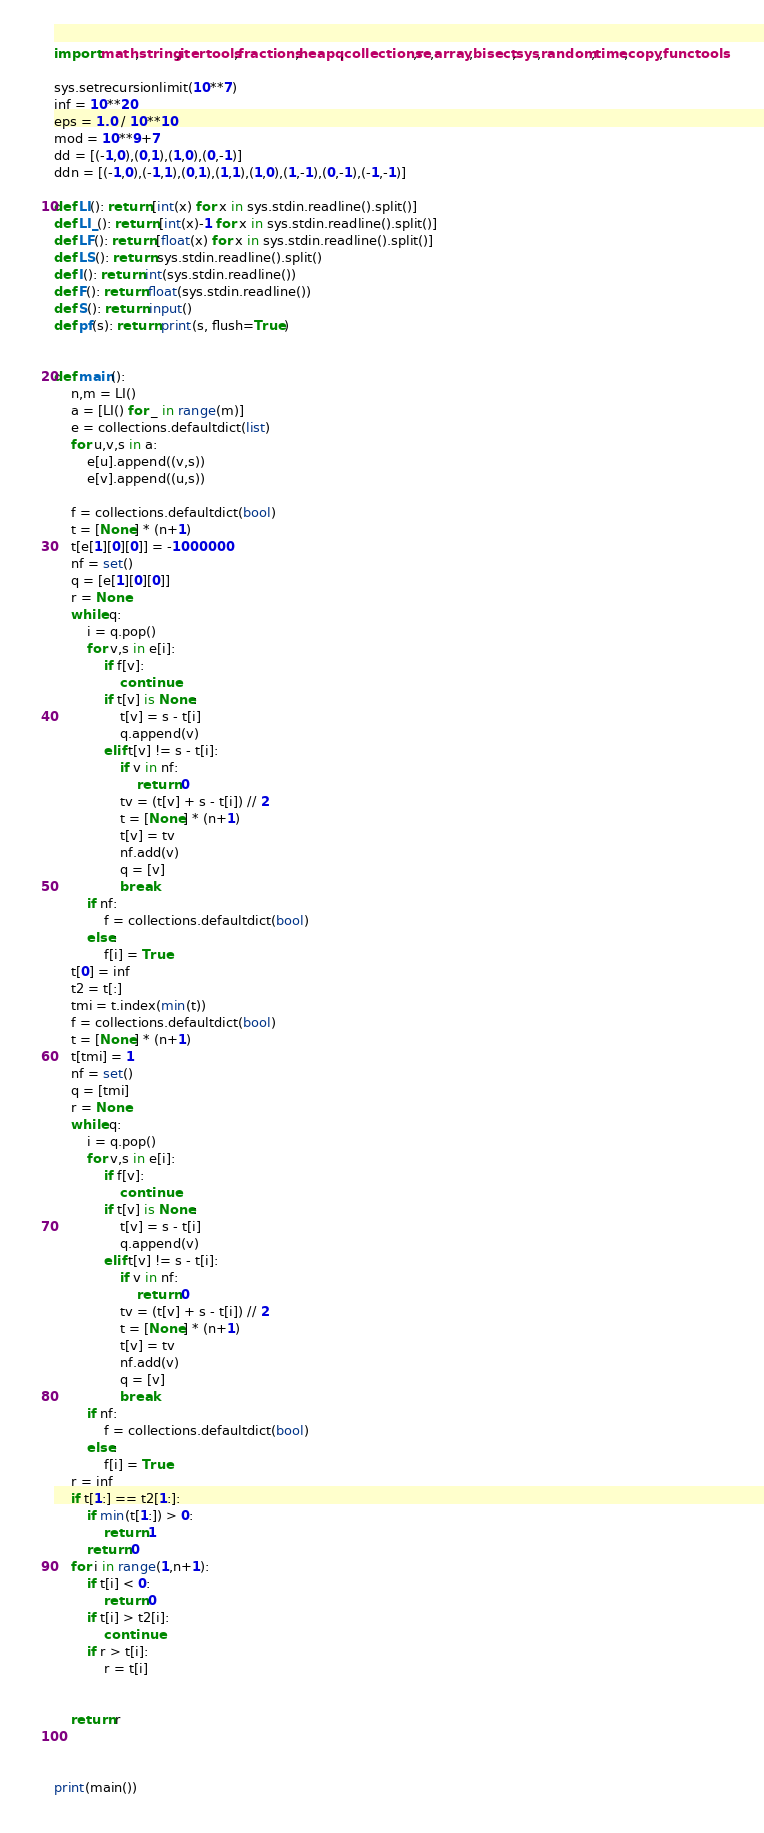<code> <loc_0><loc_0><loc_500><loc_500><_Python_>import math,string,itertools,fractions,heapq,collections,re,array,bisect,sys,random,time,copy,functools

sys.setrecursionlimit(10**7)
inf = 10**20
eps = 1.0 / 10**10
mod = 10**9+7
dd = [(-1,0),(0,1),(1,0),(0,-1)]
ddn = [(-1,0),(-1,1),(0,1),(1,1),(1,0),(1,-1),(0,-1),(-1,-1)]

def LI(): return [int(x) for x in sys.stdin.readline().split()]
def LI_(): return [int(x)-1 for x in sys.stdin.readline().split()]
def LF(): return [float(x) for x in sys.stdin.readline().split()]
def LS(): return sys.stdin.readline().split()
def I(): return int(sys.stdin.readline())
def F(): return float(sys.stdin.readline())
def S(): return input()
def pf(s): return print(s, flush=True)


def main():
    n,m = LI()
    a = [LI() for _ in range(m)]
    e = collections.defaultdict(list)
    for u,v,s in a:
        e[u].append((v,s))
        e[v].append((u,s))

    f = collections.defaultdict(bool)
    t = [None] * (n+1)
    t[e[1][0][0]] = -1000000
    nf = set()
    q = [e[1][0][0]]
    r = None
    while q:
        i = q.pop()
        for v,s in e[i]:
            if f[v]:
                continue
            if t[v] is None:
                t[v] = s - t[i]
                q.append(v)
            elif t[v] != s - t[i]:
                if v in nf:
                    return 0
                tv = (t[v] + s - t[i]) // 2
                t = [None] * (n+1)
                t[v] = tv
                nf.add(v)
                q = [v]
                break
        if nf:
            f = collections.defaultdict(bool)
        else:
            f[i] = True
    t[0] = inf
    t2 = t[:]
    tmi = t.index(min(t))
    f = collections.defaultdict(bool)
    t = [None] * (n+1)
    t[tmi] = 1
    nf = set()
    q = [tmi]
    r = None
    while q:
        i = q.pop()
        for v,s in e[i]:
            if f[v]:
                continue
            if t[v] is None:
                t[v] = s - t[i]
                q.append(v)
            elif t[v] != s - t[i]:
                if v in nf:
                    return 0
                tv = (t[v] + s - t[i]) // 2
                t = [None] * (n+1)
                t[v] = tv
                nf.add(v)
                q = [v]
                break
        if nf:
            f = collections.defaultdict(bool)
        else:
            f[i] = True
    r = inf
    if t[1:] == t2[1:]:
        if min(t[1:]) > 0:
            return 1
        return 0
    for i in range(1,n+1):
        if t[i] < 0:
            return 0
        if t[i] > t2[i]:
            continue
        if r > t[i]:
            r = t[i]


    return r



print(main())

</code> 